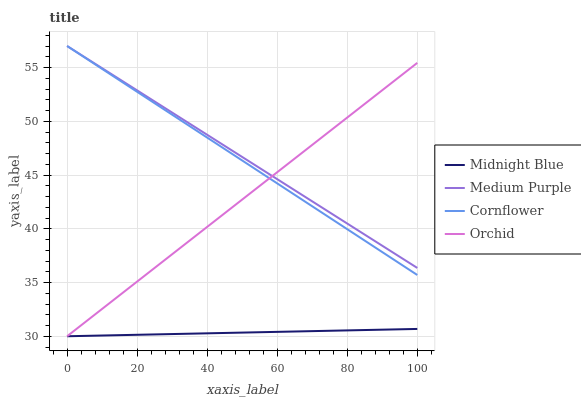Does Midnight Blue have the minimum area under the curve?
Answer yes or no. Yes. Does Medium Purple have the maximum area under the curve?
Answer yes or no. Yes. Does Cornflower have the minimum area under the curve?
Answer yes or no. No. Does Cornflower have the maximum area under the curve?
Answer yes or no. No. Is Midnight Blue the smoothest?
Answer yes or no. Yes. Is Orchid the roughest?
Answer yes or no. Yes. Is Cornflower the smoothest?
Answer yes or no. No. Is Cornflower the roughest?
Answer yes or no. No. Does Midnight Blue have the lowest value?
Answer yes or no. Yes. Does Cornflower have the lowest value?
Answer yes or no. No. Does Cornflower have the highest value?
Answer yes or no. Yes. Does Midnight Blue have the highest value?
Answer yes or no. No. Is Midnight Blue less than Cornflower?
Answer yes or no. Yes. Is Medium Purple greater than Midnight Blue?
Answer yes or no. Yes. Does Orchid intersect Medium Purple?
Answer yes or no. Yes. Is Orchid less than Medium Purple?
Answer yes or no. No. Is Orchid greater than Medium Purple?
Answer yes or no. No. Does Midnight Blue intersect Cornflower?
Answer yes or no. No. 